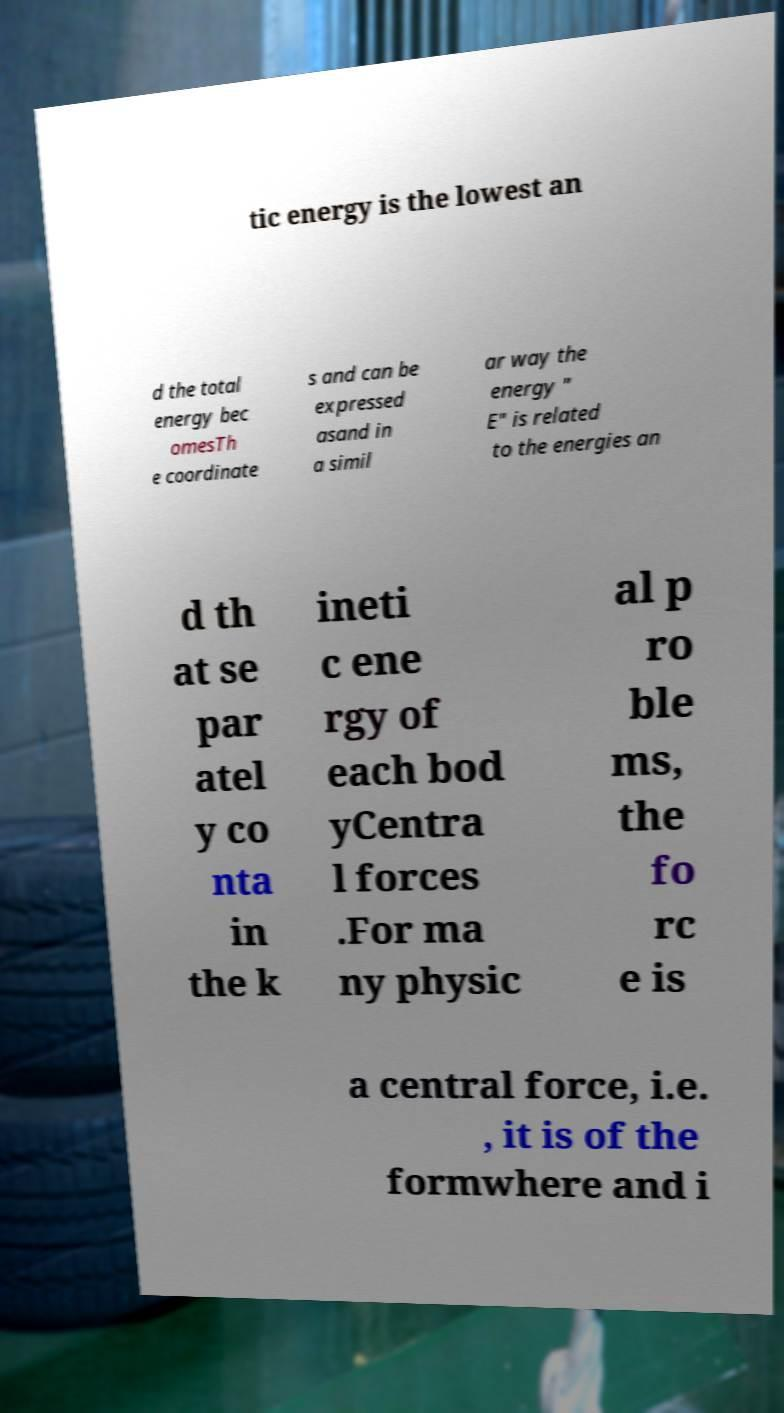Could you extract and type out the text from this image? tic energy is the lowest an d the total energy bec omesTh e coordinate s and can be expressed asand in a simil ar way the energy " E" is related to the energies an d th at se par atel y co nta in the k ineti c ene rgy of each bod yCentra l forces .For ma ny physic al p ro ble ms, the fo rc e is a central force, i.e. , it is of the formwhere and i 